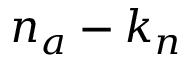Convert formula to latex. <formula><loc_0><loc_0><loc_500><loc_500>n _ { a } - k _ { n }</formula> 